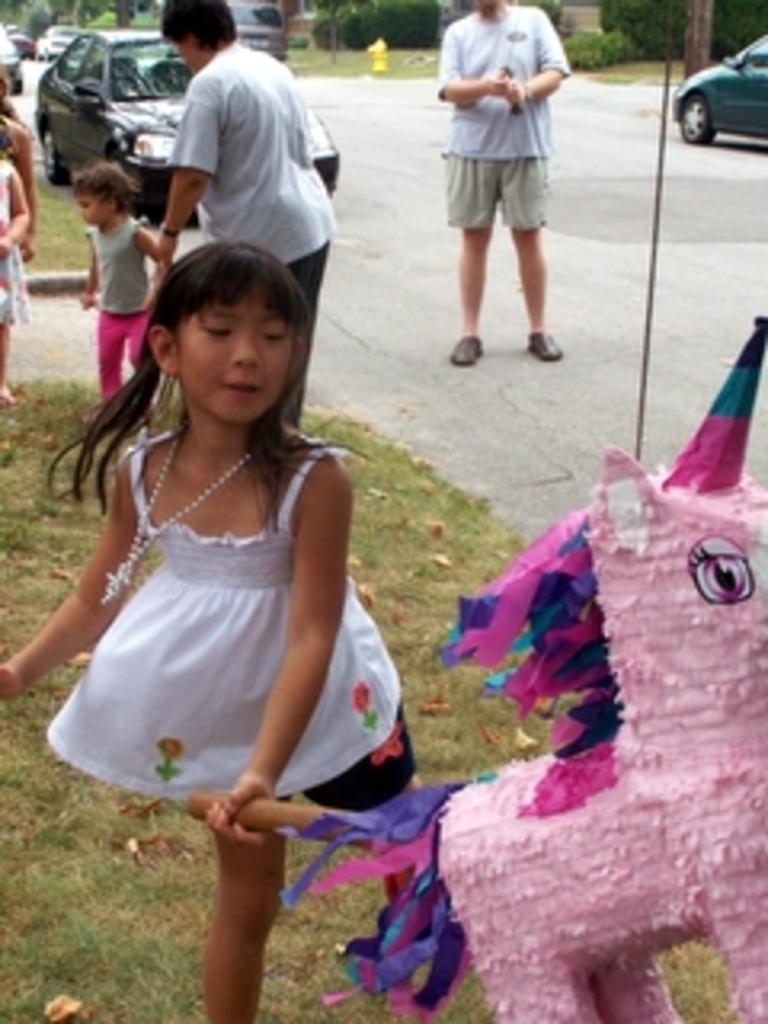How would you summarize this image in a sentence or two? In this image we can see people standing on the ground and a child is playing with the toy. In the background there are motor vehicles on the road, trees and shrubs. 